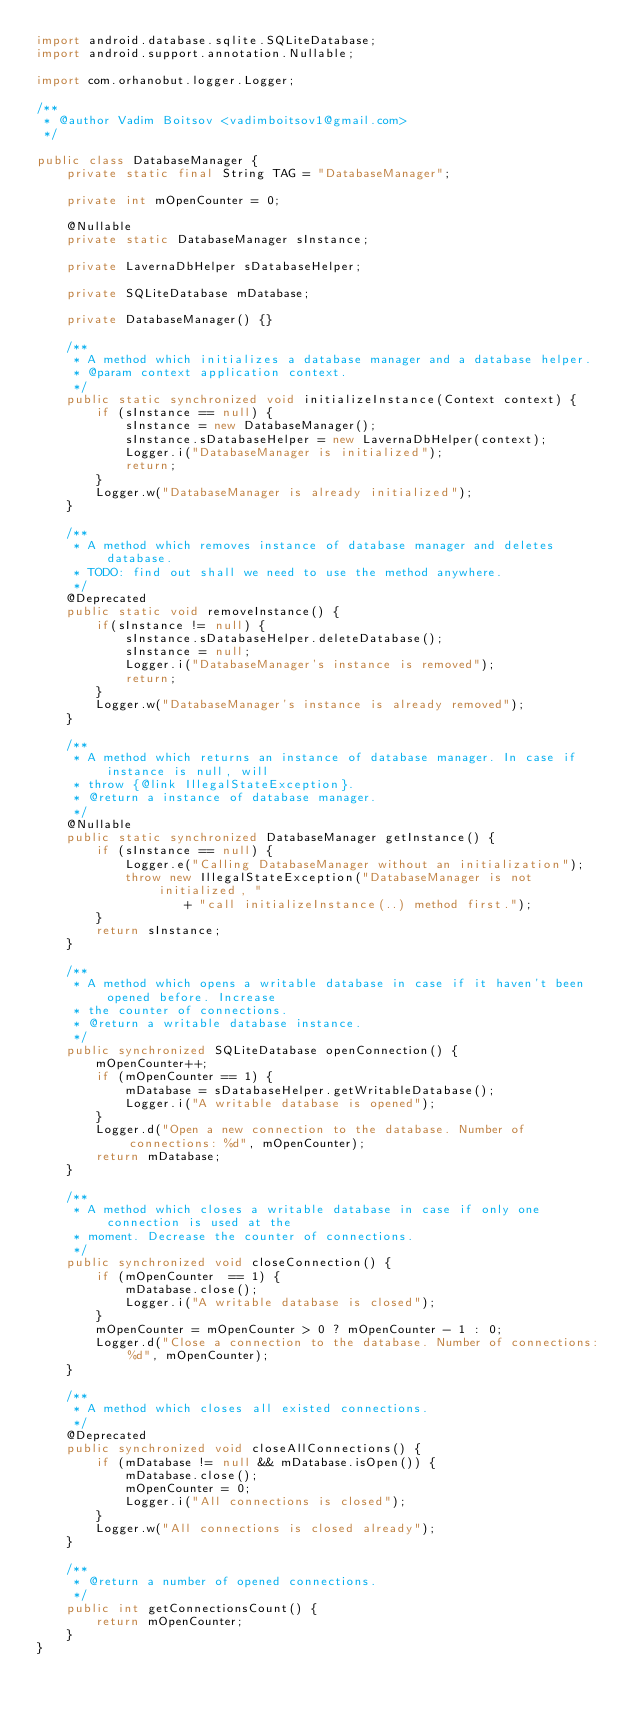Convert code to text. <code><loc_0><loc_0><loc_500><loc_500><_Java_>import android.database.sqlite.SQLiteDatabase;
import android.support.annotation.Nullable;

import com.orhanobut.logger.Logger;

/**
 * @author Vadim Boitsov <vadimboitsov1@gmail.com>
 */

public class DatabaseManager {
    private static final String TAG = "DatabaseManager";

    private int mOpenCounter = 0;

    @Nullable
    private static DatabaseManager sInstance;

    private LavernaDbHelper sDatabaseHelper;

    private SQLiteDatabase mDatabase;

    private DatabaseManager() {}

    /**
     * A method which initializes a database manager and a database helper.
     * @param context application context.
     */
    public static synchronized void initializeInstance(Context context) {
        if (sInstance == null) {
            sInstance = new DatabaseManager();
            sInstance.sDatabaseHelper = new LavernaDbHelper(context);
            Logger.i("DatabaseManager is initialized");
            return;
        }
        Logger.w("DatabaseManager is already initialized");
    }

    /**
     * A method which removes instance of database manager and deletes database.
     * TODO: find out shall we need to use the method anywhere.
     */
    @Deprecated
    public static void removeInstance() {
        if(sInstance != null) {
            sInstance.sDatabaseHelper.deleteDatabase();
            sInstance = null;
            Logger.i("DatabaseManager's instance is removed");
            return;
        }
        Logger.w("DatabaseManager's instance is already removed");
    }

    /**
     * A method which returns an instance of database manager. In case if instance is null, will
     * throw {@link IllegalStateException}.
     * @return a instance of database manager.
     */
    @Nullable
    public static synchronized DatabaseManager getInstance() {
        if (sInstance == null) {
            Logger.e("Calling DatabaseManager without an initialization");
            throw new IllegalStateException("DatabaseManager is not initialized, "
                    + "call initializeInstance(..) method first.");
        }
        return sInstance;
    }

    /**
     * A method which opens a writable database in case if it haven't been opened before. Increase
     * the counter of connections.
     * @return a writable database instance.
     */
    public synchronized SQLiteDatabase openConnection() {
        mOpenCounter++;
        if (mOpenCounter == 1) {
            mDatabase = sDatabaseHelper.getWritableDatabase();
            Logger.i("A writable database is opened");
        }
        Logger.d("Open a new connection to the database. Number of connections: %d", mOpenCounter);
        return mDatabase;
    }

    /**
     * A method which closes a writable database in case if only one connection is used at the
     * moment. Decrease the counter of connections.
     */
    public synchronized void closeConnection() {
        if (mOpenCounter  == 1) {
            mDatabase.close();
            Logger.i("A writable database is closed");
        }
        mOpenCounter = mOpenCounter > 0 ? mOpenCounter - 1 : 0;
        Logger.d("Close a connection to the database. Number of connections: %d", mOpenCounter);
    }

    /**
     * A method which closes all existed connections.
     */
    @Deprecated
    public synchronized void closeAllConnections() {
        if (mDatabase != null && mDatabase.isOpen()) {
            mDatabase.close();
            mOpenCounter = 0;
            Logger.i("All connections is closed");
        }
        Logger.w("All connections is closed already");
    }

    /**
     * @return a number of opened connections.
     */
    public int getConnectionsCount() {
        return mOpenCounter;
    }
}

</code> 